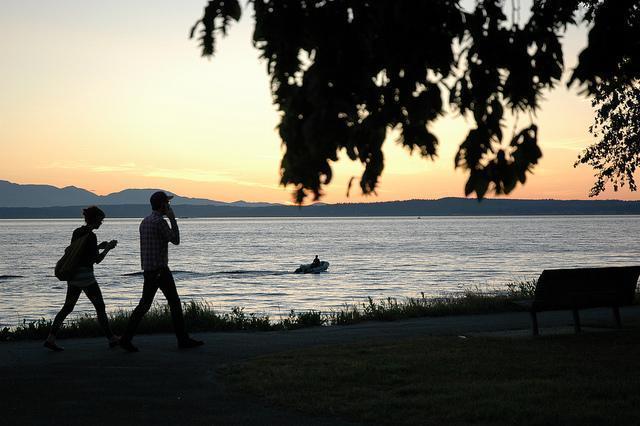How many boats r in the water?
Give a very brief answer. 1. How many boats are in the water?
Give a very brief answer. 1. How many people are in the picture?
Give a very brief answer. 2. How many benches are there?
Give a very brief answer. 1. 